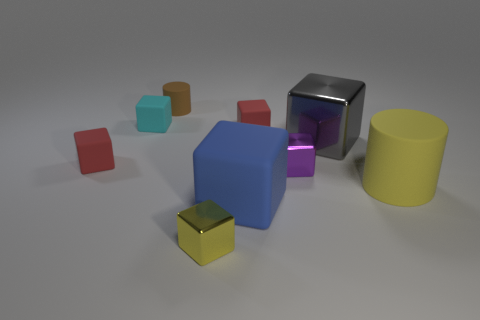Do the yellow metallic object and the large gray shiny thing have the same shape?
Keep it short and to the point. Yes. What number of rubber objects are both on the right side of the tiny yellow metal thing and to the left of the big gray metallic object?
Provide a short and direct response. 2. The small cyan object that is the same material as the small brown cylinder is what shape?
Make the answer very short. Cube. Do the purple cube and the brown thing have the same size?
Provide a succinct answer. Yes. Are there an equal number of large gray shiny blocks that are behind the small cyan block and large rubber cylinders right of the blue block?
Your answer should be very brief. No. What is the shape of the brown object?
Ensure brevity in your answer.  Cylinder. The thing that is the same color as the large cylinder is what size?
Make the answer very short. Small. What size is the cylinder that is to the right of the small cylinder?
Provide a short and direct response. Large. Are there fewer yellow matte cylinders that are right of the small cylinder than metallic things on the right side of the large blue block?
Your answer should be compact. Yes. What color is the large rubber cylinder?
Your answer should be compact. Yellow. 